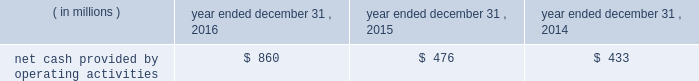Special purpose entity ( 201cspe 201d ) .
The spe obtained a term loan and revolving loan commitment from a third party lender , secured by liens on the assets of the spe , to finance the purchase of the accounts receivable , which included a $ 275 million term loan and a $ 25 million revolving loan commitment .
The revolving loan commitment may be increased by an additional $ 35 million as amounts are repaid under the term loan .
Quintilesims has guaranteed the performance of the obligations of existing and future subsidiaries that sell and service the accounts receivable under the receivables financing facility .
The assets of the spe are not available to satisfy any of our obligations or any obligations of our subsidiaries .
As of december 31 , 2016 , the full $ 25 million of revolving loan commitment was available under the receivables financing facility .
We used the proceeds from the term loan under the receivables financing facility to repay in full the amount outstanding on the then outstanding revolving credit facility under its then outstanding senior secured credit agreement ( $ 150 million ) , to repay $ 25 million of the then outstanding term loan b-3 , to pay related fees and expenses and the remainder was used for general working capital purposes .
Restrictive covenants our debt agreements provide for certain covenants and events of default customary for similar instruments , including a covenant not to exceed a specified ratio of consolidated senior secured net indebtedness to consolidated ebitda , as defined in the senior secured credit facility and a covenant to maintain a specified minimum interest coverage ratio .
If an event of default occurs under any of the company 2019s or the company 2019s subsidiaries 2019 financing arrangements , the creditors under such financing arrangements will be entitled to take various actions , including the acceleration of amounts due under such arrangements , and in the case of the lenders under the revolving credit facility and new term loans , other actions permitted to be taken by a secured creditor .
Our long-term debt arrangements contain usual and customary restrictive covenants that , among other things , place limitations on our ability to declare dividends .
For additional information regarding these restrictive covenants , see part ii , item 5 201cmarket for registrant 2019s common equity , related stockholder matters and issuer purchases of equity securities 2014dividend policy 201d and note 11 to our audited consolidated financial statements included elsewhere in this annual report on form 10-k .
At december 31 , 2016 , the company was in compliance with the financial covenants under the company 2019s financing arrangements .
Years ended december 31 , 2016 , 2015 and 2014 cash flow from operating activities .
2016 compared to 2015 cash provided by operating activities increased $ 384 million in 2016 as compared to 2015 .
The increase in cash provided by operating activities reflects the increase in net income as adjusted for non-cash items necessary to reconcile net income to cash provided by operating activities .
Also contributing to the increase were lower payments for income taxes ( $ 15 million ) , and lower cash used in days sales outstanding ( 201cdso 201d ) and accounts payable and accrued expenses .
The lower cash used in dso reflects a two-day increase in dso in 2016 compared to a seven-day increase in dso in 2015 .
Dso can shift significantly at each reporting period depending on the timing of cash receipts under contractual payment terms relative to the recognition of revenue over a project lifecycle. .
What is the percent increase in net cash provided by operating activities from 2014 to 2015? 
Computations: ((476 - 433) / 433)
Answer: 0.09931. 